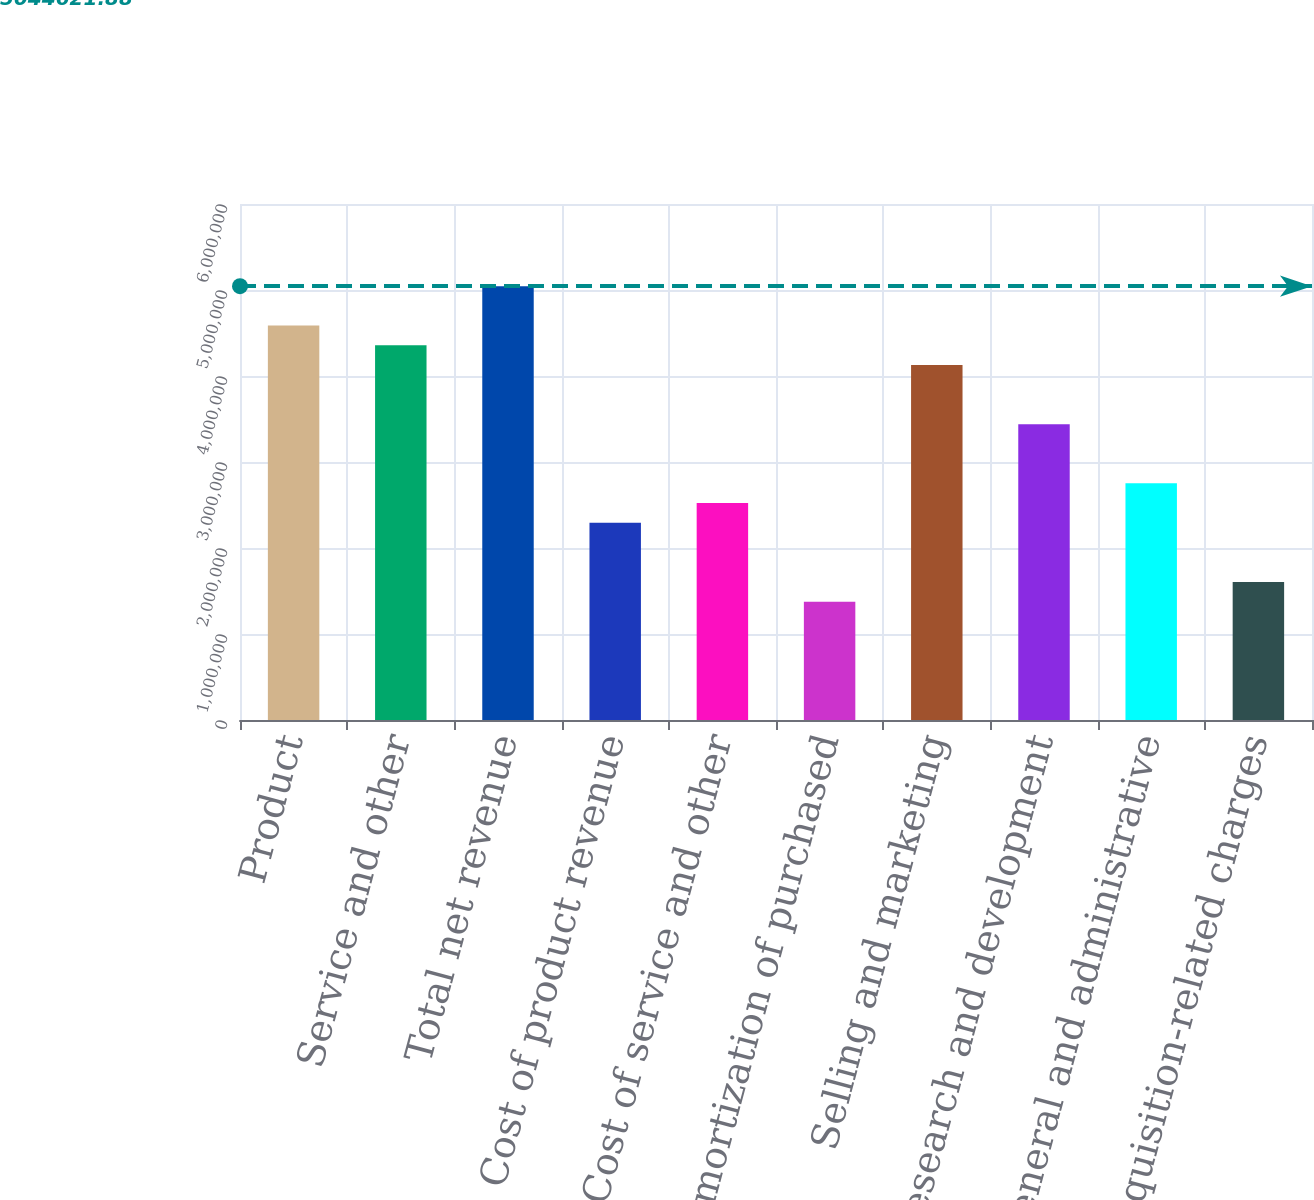<chart> <loc_0><loc_0><loc_500><loc_500><bar_chart><fcel>Product<fcel>Service and other<fcel>Total net revenue<fcel>Cost of product revenue<fcel>Cost of service and other<fcel>Amortization of purchased<fcel>Selling and marketing<fcel>Research and development<fcel>General and administrative<fcel>Acquisition-related charges<nl><fcel>4.58602e+06<fcel>4.35672e+06<fcel>5.04462e+06<fcel>2.29301e+06<fcel>2.52231e+06<fcel>1.37581e+06<fcel>4.12742e+06<fcel>3.43951e+06<fcel>2.75161e+06<fcel>1.60511e+06<nl></chart> 